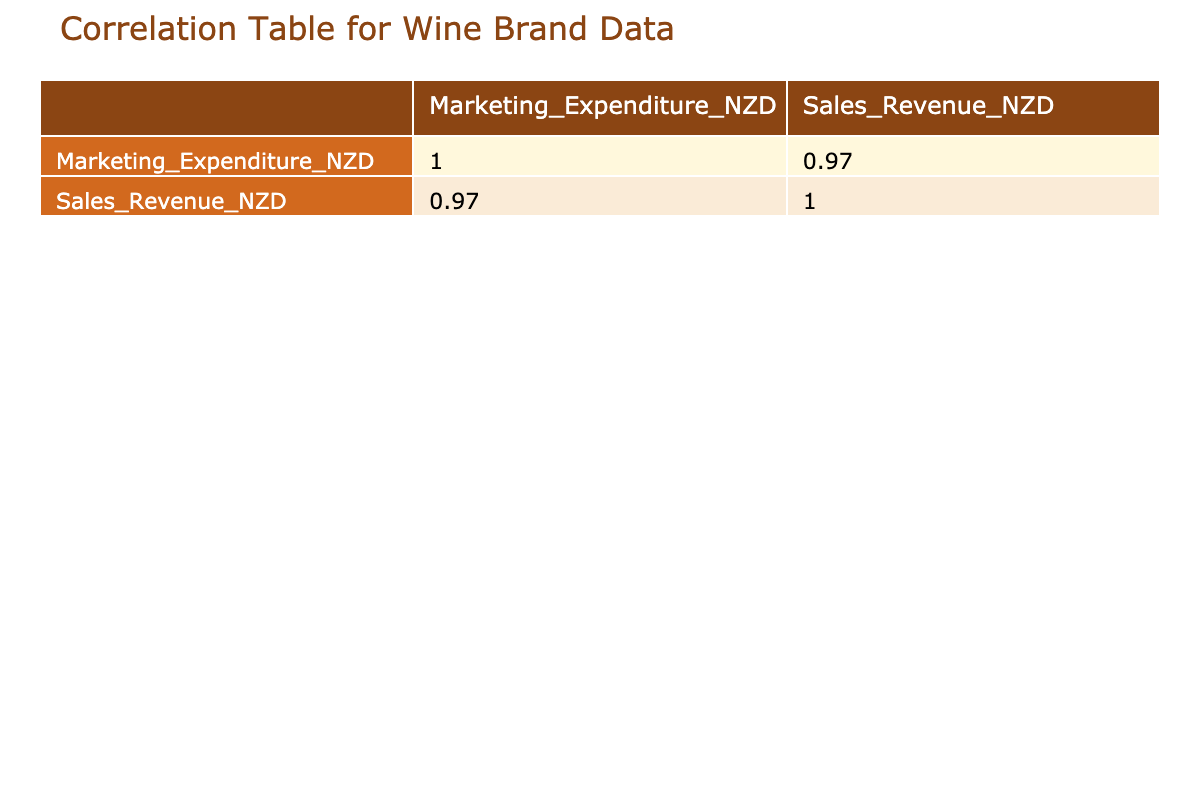What is the marketing expenditure of Villa Maria? The table lists the marketing expenditure for each wine brand, and for Villa Maria, it shows 300000 NZD.
Answer: 300000 NZD What is the sales revenue for Craggy Range? The sales revenue column indicates that Craggy Range has a sales revenue of 2500000 NZD.
Answer: 2500000 NZD Is the marketing expenditure for Te Mata Estate greater than 300000 NZD? According to the table, Te Mata Estate's marketing expenditure is 350000 NZD, which is indeed greater than 300000 NZD.
Answer: Yes What is the difference between the sales revenue of Cloudy Bay and Mud House? Cloudy Bay has a sales revenue of 1500000 NZD and Mud House has a sales revenue of 1200000 NZD. The difference is 1500000 - 1200000 = 300000 NZD.
Answer: 300000 NZD Which brand has the highest marketing expenditure and what is the value? The table shows that Craggy Range has the highest marketing expenditure at 400000 NZD.
Answer: 400000 NZD What is the average sales revenue across all brands? To find the average, sum all the sales revenues: 1500000 + 900000 + 2000000 + 2500000 + 1200000 + 1350000 + 600000 + 300000 + 800000 + 1800000 = 12200000 NZD. There are 10 brands, thus the average is 12200000 / 10 = 1220000 NZD.
Answer: 1220000 NZD Is there any brand with a marketing expenditure less than 100000 NZD? In the table, both Fromm Winery (80000 NZD) and Maimai Wines (50000 NZD) have marketing expenditures less than 100000 NZD.
Answer: Yes What is the total marketing expenditure for all the brands combined? Adding all marketing expenditures: 250000 + 100000 + 300000 + 400000 + 150000 + 200000 + 80000 + 50000 + 120000 + 350000 = 1950000 NZD.
Answer: 1950000 NZD Which brand has a sales revenue lower than 1300000 NZD? From the table, we can see that the brands with sales revenue lower than 1300000 NZD are Kai Schubel (900000 NZD), Mud House (1200000 NZD), Fromm Winery (600000 NZD), and Maimai Wines (300000 NZD).
Answer: Kai Schubel, Mud House, Fromm Winery, Maimai Wines What is the correlation between marketing expenditure and sales revenue? To determine this, we analyze the correlation matrix from the table, which typically reveals whether higher marketing expenditure leads to higher sales revenue. In this specific context, one would observe that the correlation coefficient would provide this insight.
Answer: High positive correlation (exact value not provided) 